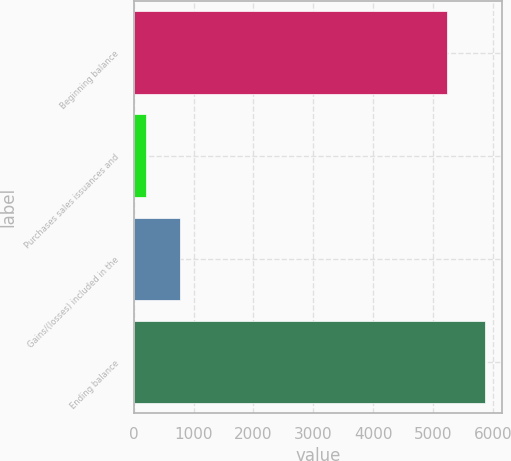Convert chart to OTSL. <chart><loc_0><loc_0><loc_500><loc_500><bar_chart><fcel>Beginning balance<fcel>Purchases sales issuances and<fcel>Gains/(losses) included in the<fcel>Ending balance<nl><fcel>5234.9<fcel>209.1<fcel>774.73<fcel>5865.4<nl></chart> 